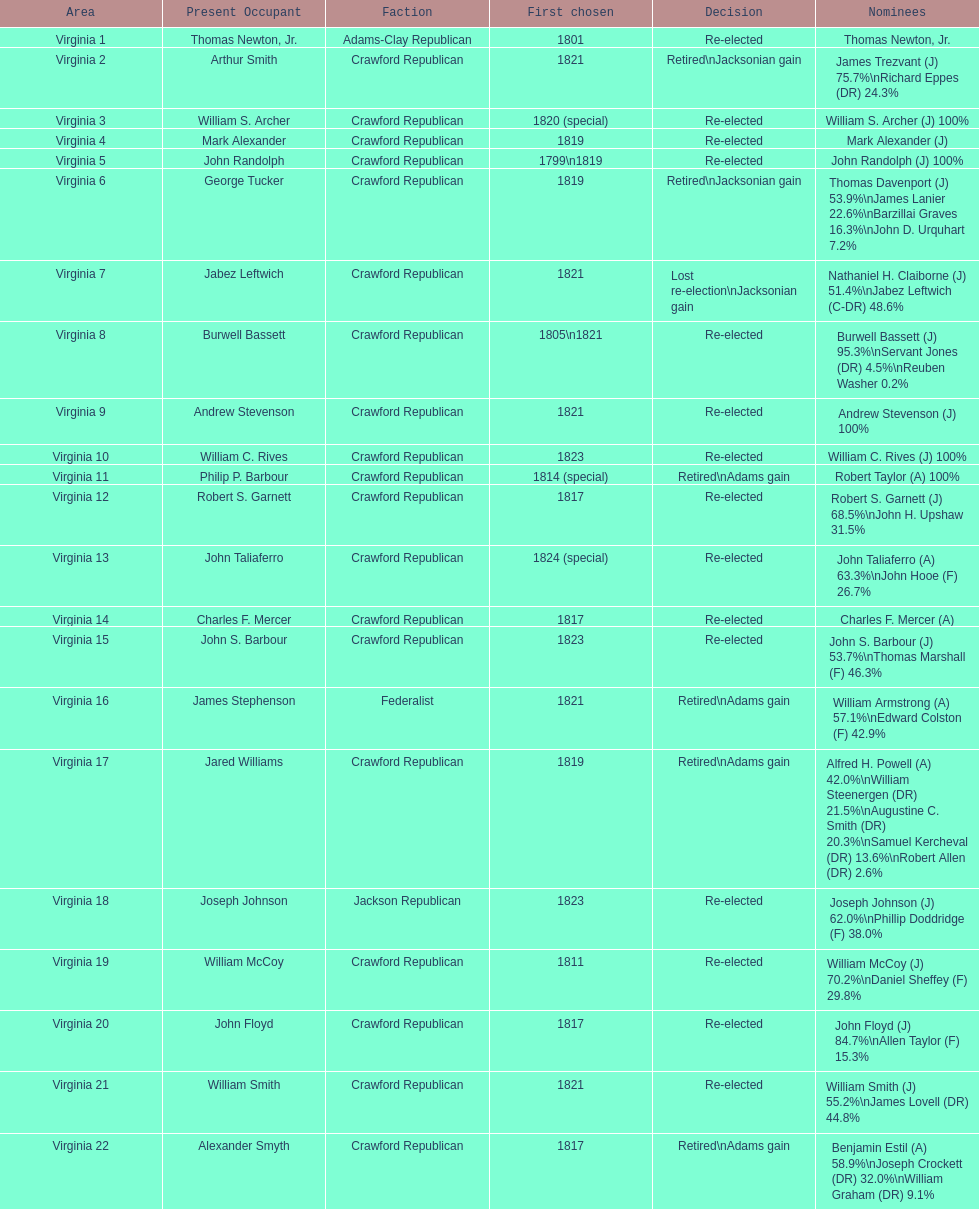Tell me the number of people first elected in 1817. 4. 